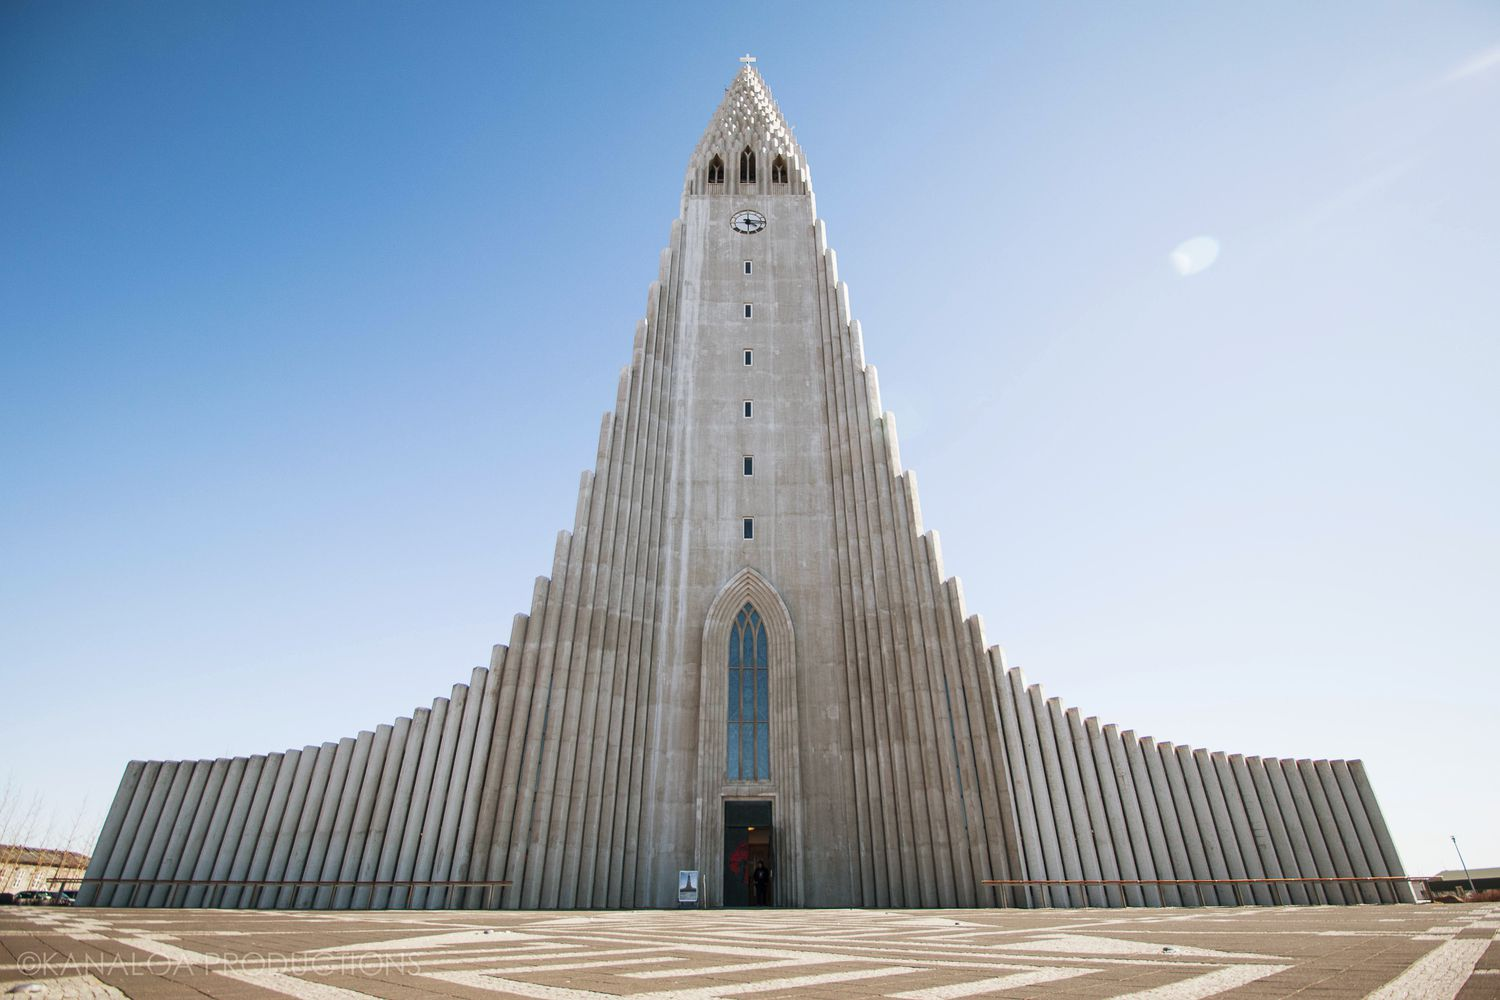What is this photo about? The photo showcases Hallgrímskirkja, a prominent Lutheran church in Reykjavík, Iceland. Notable for its soaring architecture inspired by Iceland's natural landscapes, particularly the basalt lava flows, the church is a fine example of expressionist architecture. Built in 1986, the church is among Iceland’s tallest structures and serves both as a place of worship and a tourist attraction. This image captures the church on a clear day, where the sharp vertical lines of the concrete facade contrast dramatically with the bright blue sky. The towering presence and unique design make it a captivating subject for photography and a symbolic landmark representing Iceland’s cultural heritage. 